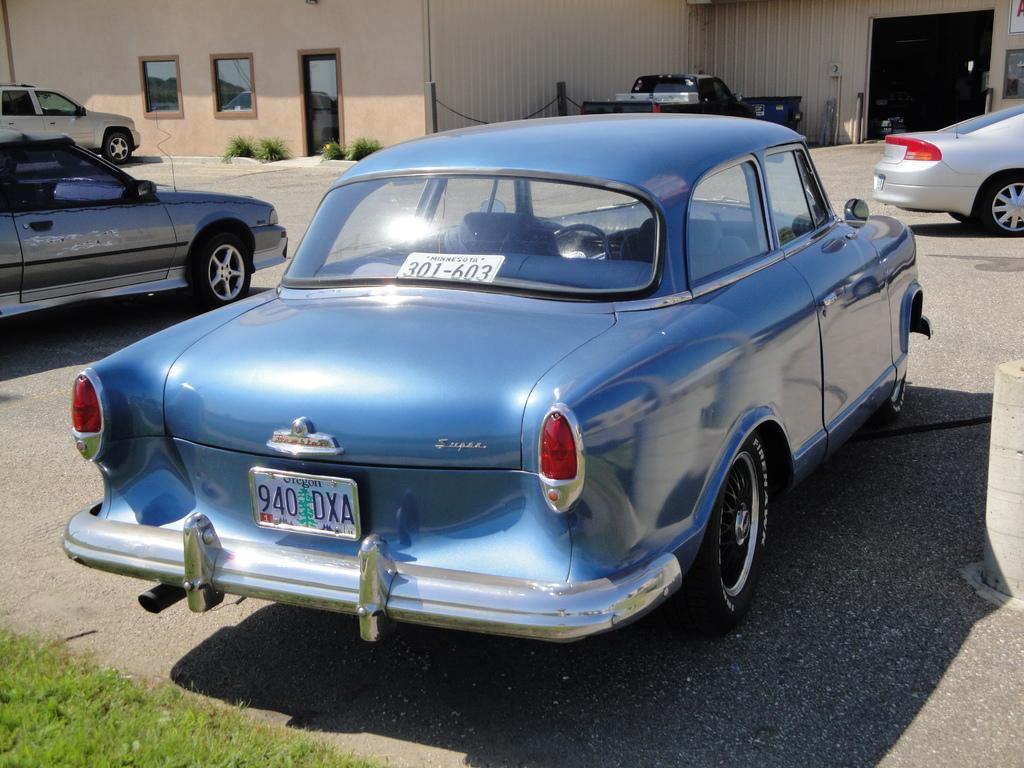Please provide a concise description of this image. In this image I see the path on which there are 5 cars and I see a building and I see the plants over here and I see the green grass over here and it is dark over here. 